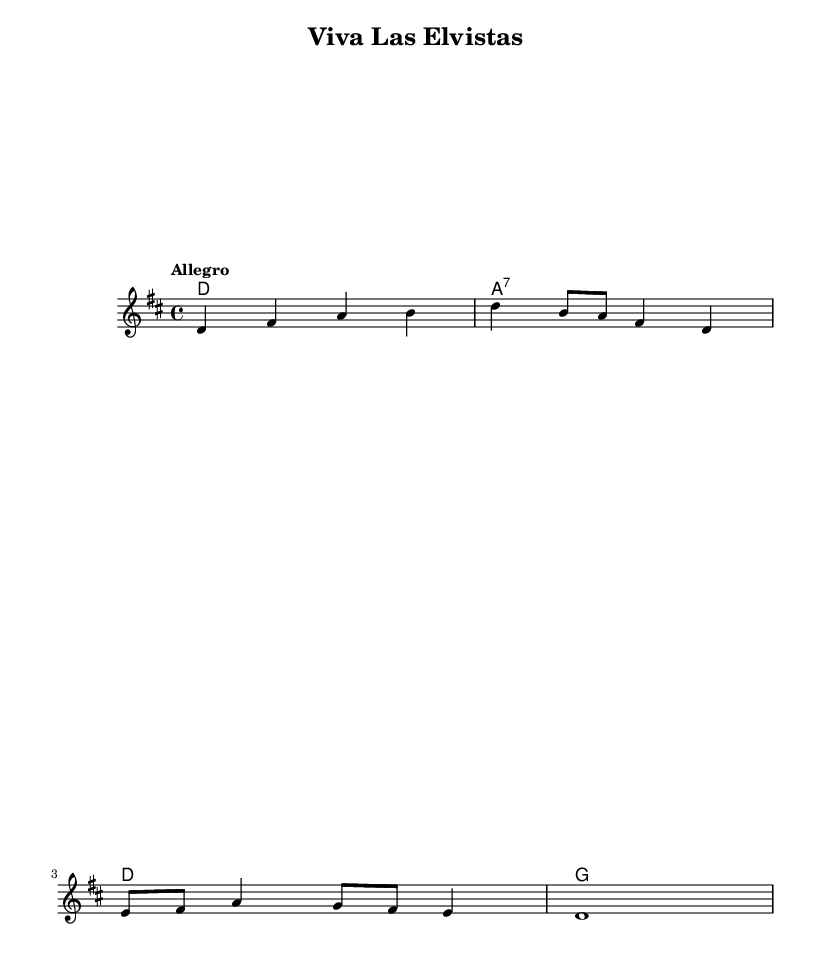What is the key signature of this music? The key signature is indicated by the sharp sign on the staff. In this case, there are two sharps, which corresponds to D major.
Answer: D major What is the time signature of the piece? The time signature is shown at the beginning of the music. Here, it is indicated as 4/4, meaning there are four beats in each measure and a quarter note receives one beat.
Answer: 4/4 What is the tempo marking for the piece? The tempo marking is included and is typically placed above the staff. It states "Allegro," which indicates a fast pace for the music.
Answer: Allegro How many measures are in the melody? To determine the number of measures, one counts the vertical bar lines separating the music into measures. The melody provided has four measures.
Answer: 4 Which chord is played on the first measure? The first measure's chord is listed in the chord names section. It shows a D major chord.
Answer: D major Identify the last note of the melody. By looking at the melody line, the last note shown is a whole note (d1), which means it lasts for a full measure and is located in the last measure.
Answer: D What type of music styles can be represented by this piece? The music is labeled as "Latin-inspired" tribute, which generally includes influences from Latin rhythms and melodies. This style complements the Elvis tribute aspect.
Answer: Latin-inspired 